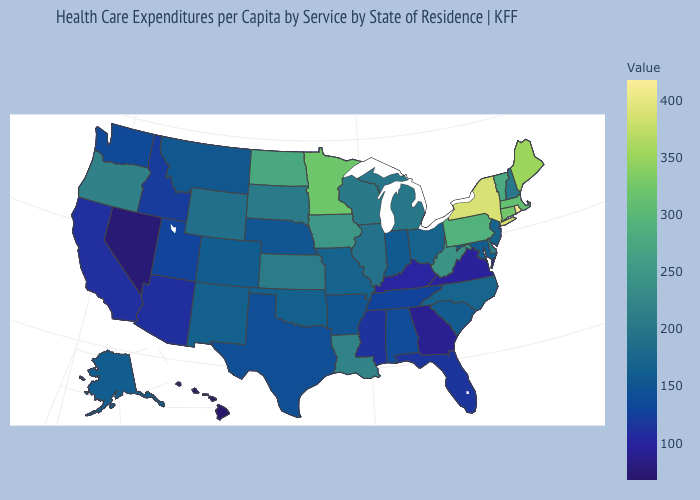Does Connecticut have a lower value than Kentucky?
Write a very short answer. No. Does Utah have a higher value than Georgia?
Write a very short answer. Yes. Does Rhode Island have the highest value in the USA?
Keep it brief. Yes. Which states have the highest value in the USA?
Answer briefly. Rhode Island. Among the states that border Montana , which have the highest value?
Be succinct. North Dakota. Does the map have missing data?
Short answer required. No. 